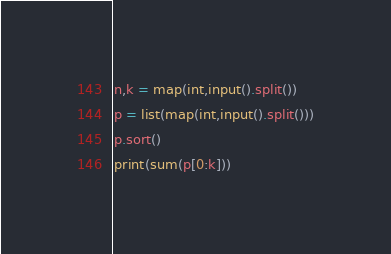<code> <loc_0><loc_0><loc_500><loc_500><_Python_>n,k = map(int,input().split())	
p = list(map(int,input().split()))
p.sort()
print(sum(p[0:k]))</code> 